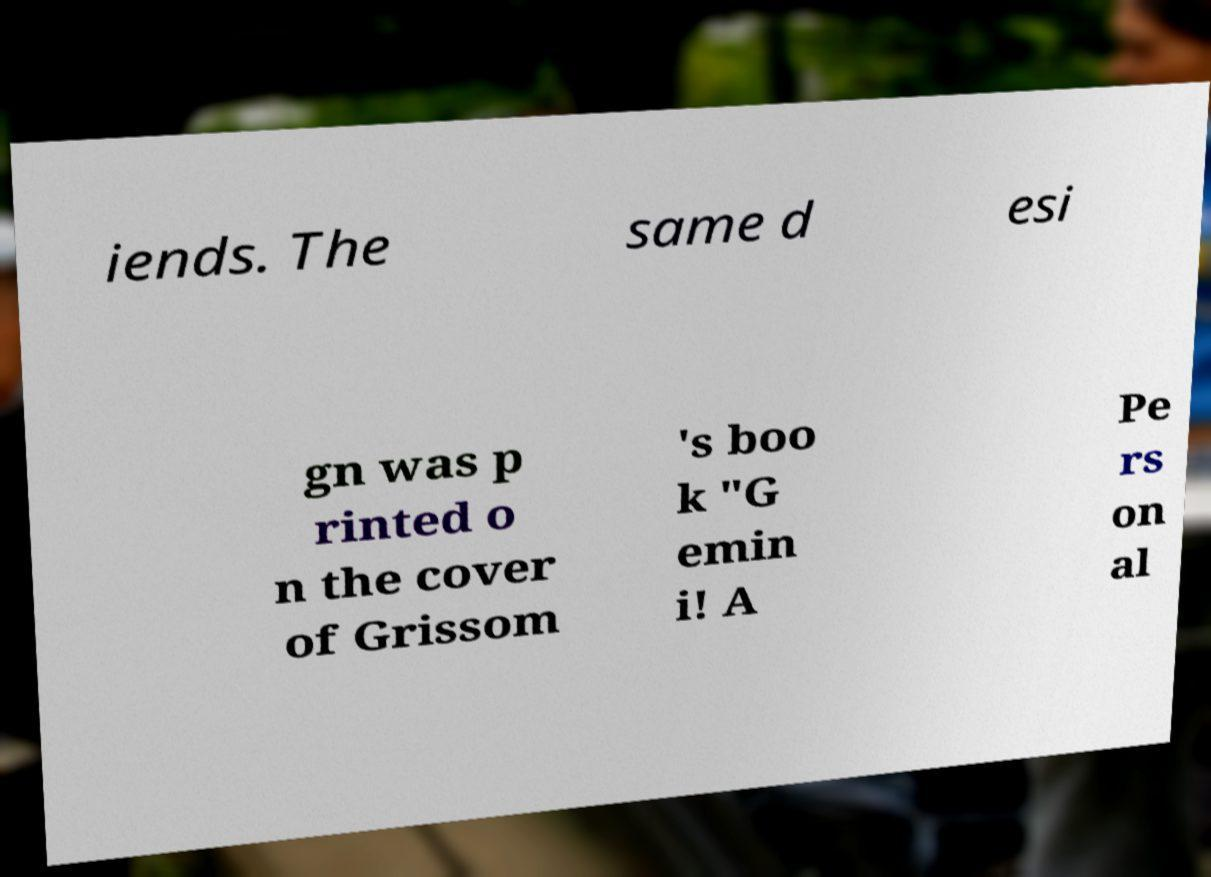Please read and relay the text visible in this image. What does it say? iends. The same d esi gn was p rinted o n the cover of Grissom 's boo k "G emin i! A Pe rs on al 